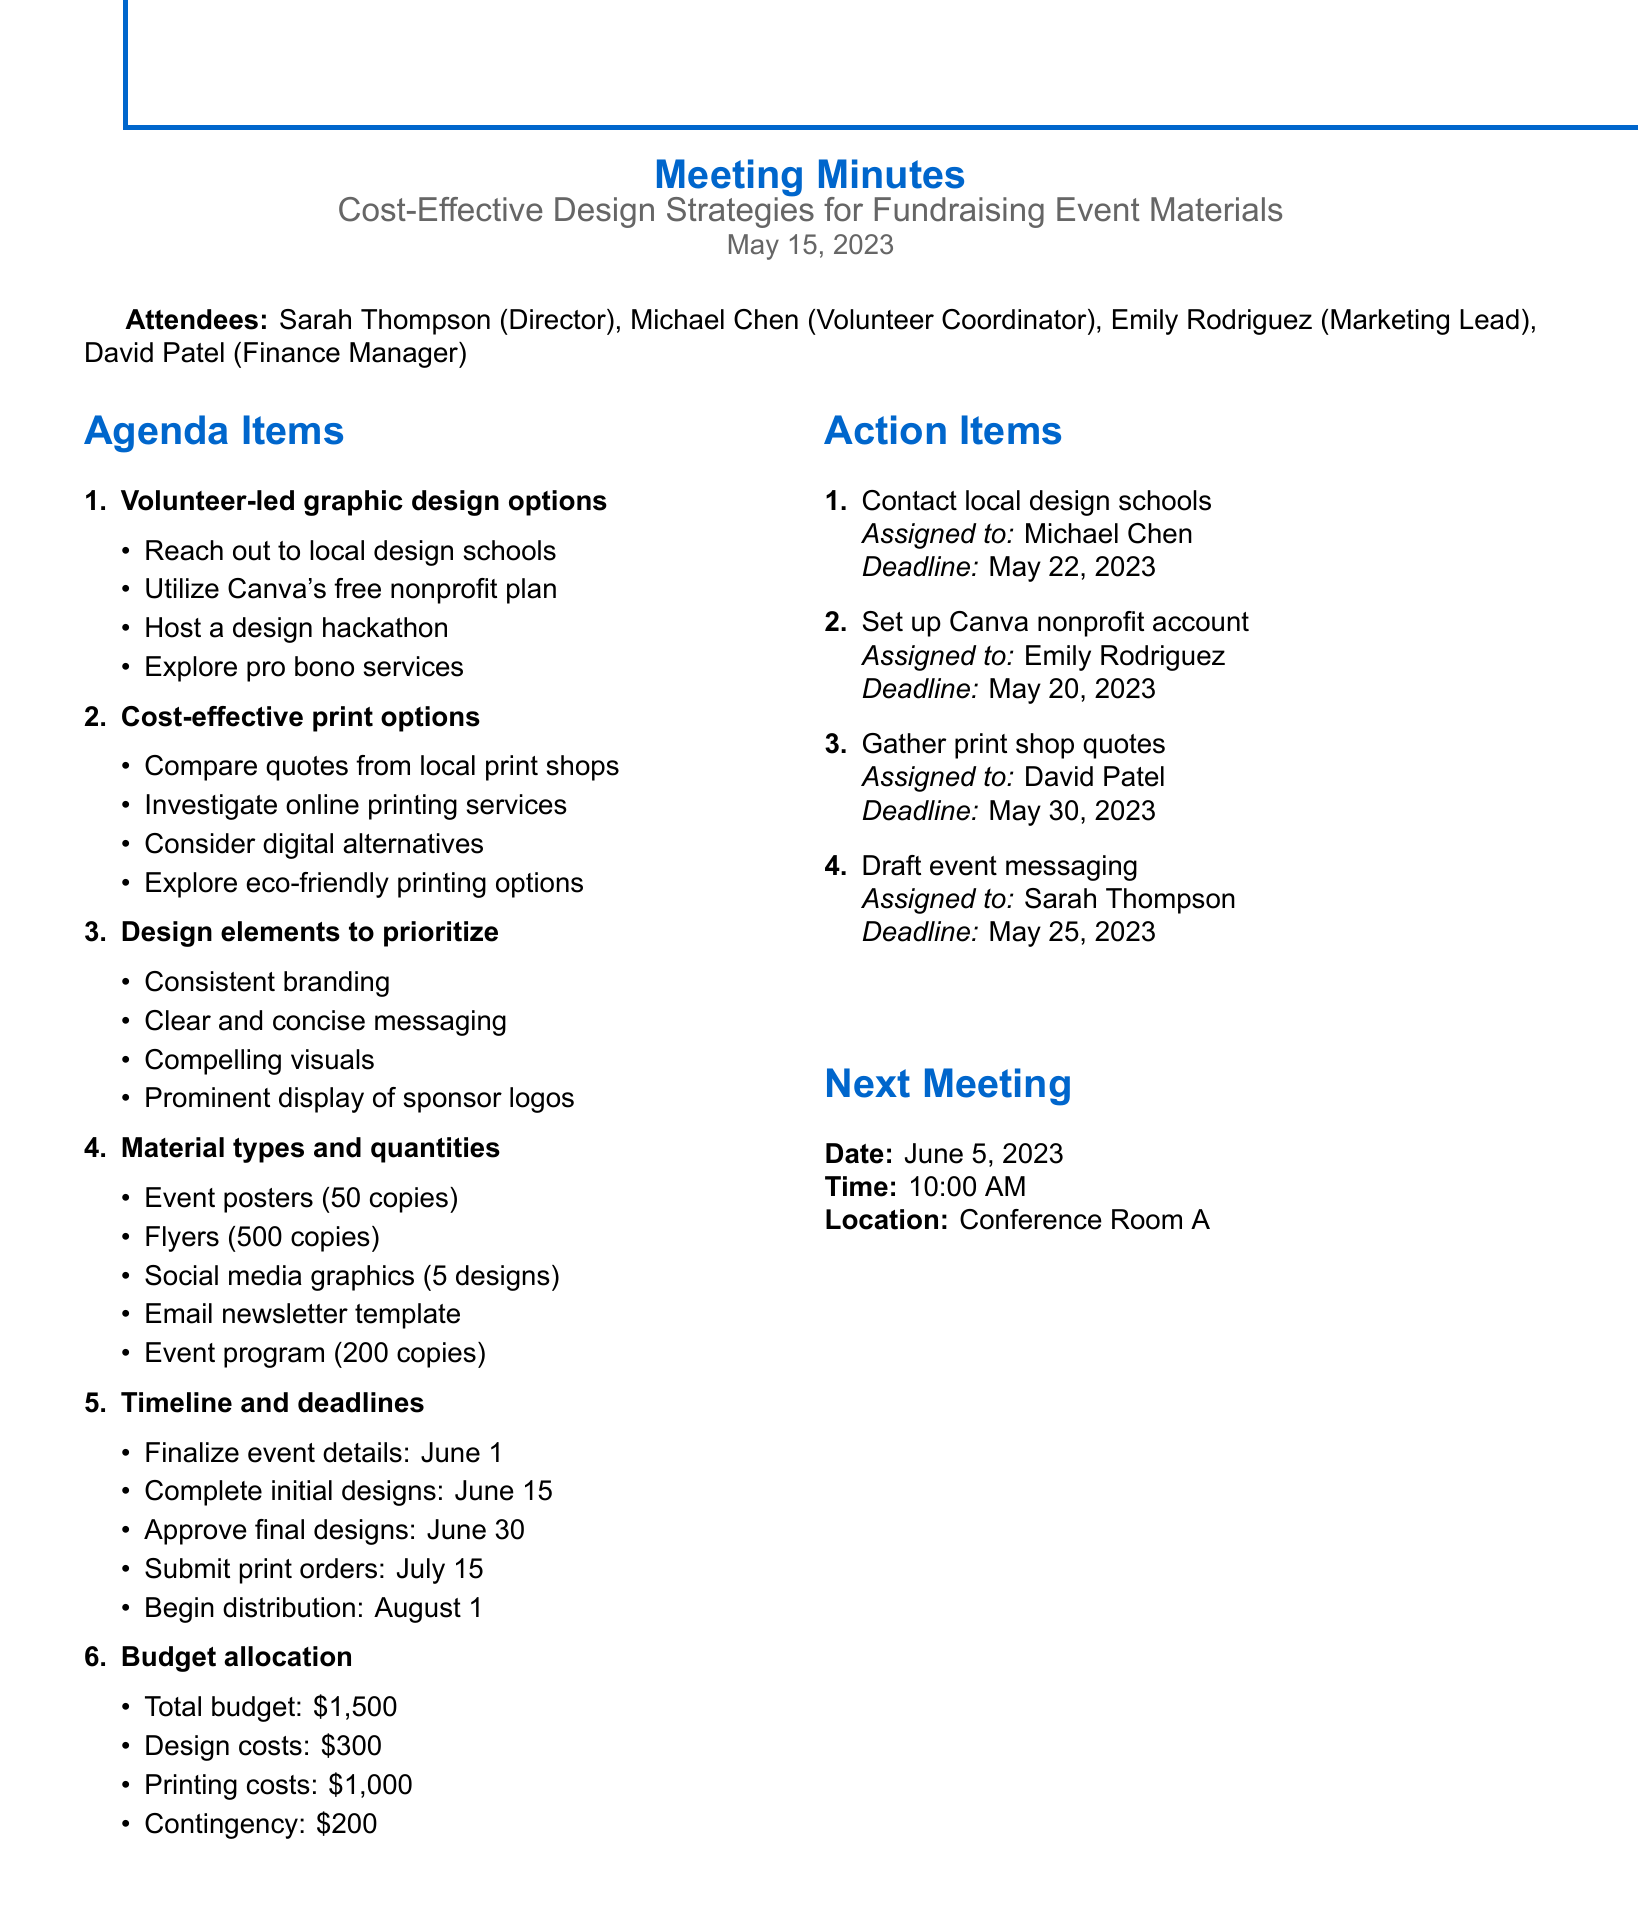What is the date of the meeting? The date of the meeting is stated in the document header as May 15, 2023.
Answer: May 15, 2023 Who is responsible for contacting local design schools? The action item assigned to contact local design schools is given to Michael Chen.
Answer: Michael Chen What is the total budget for the fundraising event? The total budget mentioned in the budget allocation section is given as $1,500.
Answer: $1,500 What type of event material has a quantity of 500 copies? The document specifies that there will be 500 copies of flyers for street distribution and mailings.
Answer: Flyers By when should the initial designs be completed? The timeline includes a deadline for completing the initial designs by June 15, as listed.
Answer: June 15 What are the two categories discussed under cost-effective print options? The cost-effective print options discussed include comparing quotes from local print shops and investigating online printing services.
Answer: Local print shops and online printing services Which design element is prioritized for consistent branding? The consistent branding element includes the logo, color scheme, and typography as mentioned in the discussion points.
Answer: Consistent branding What is the assigned deadline for the event messaging draft? The document states that the deadline to draft event messaging is May 25, 2023.
Answer: May 25, 2023 